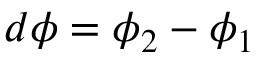<formula> <loc_0><loc_0><loc_500><loc_500>d \phi = \phi _ { 2 } - \phi _ { 1 }</formula> 